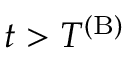Convert formula to latex. <formula><loc_0><loc_0><loc_500><loc_500>t > T ^ { ( B ) }</formula> 